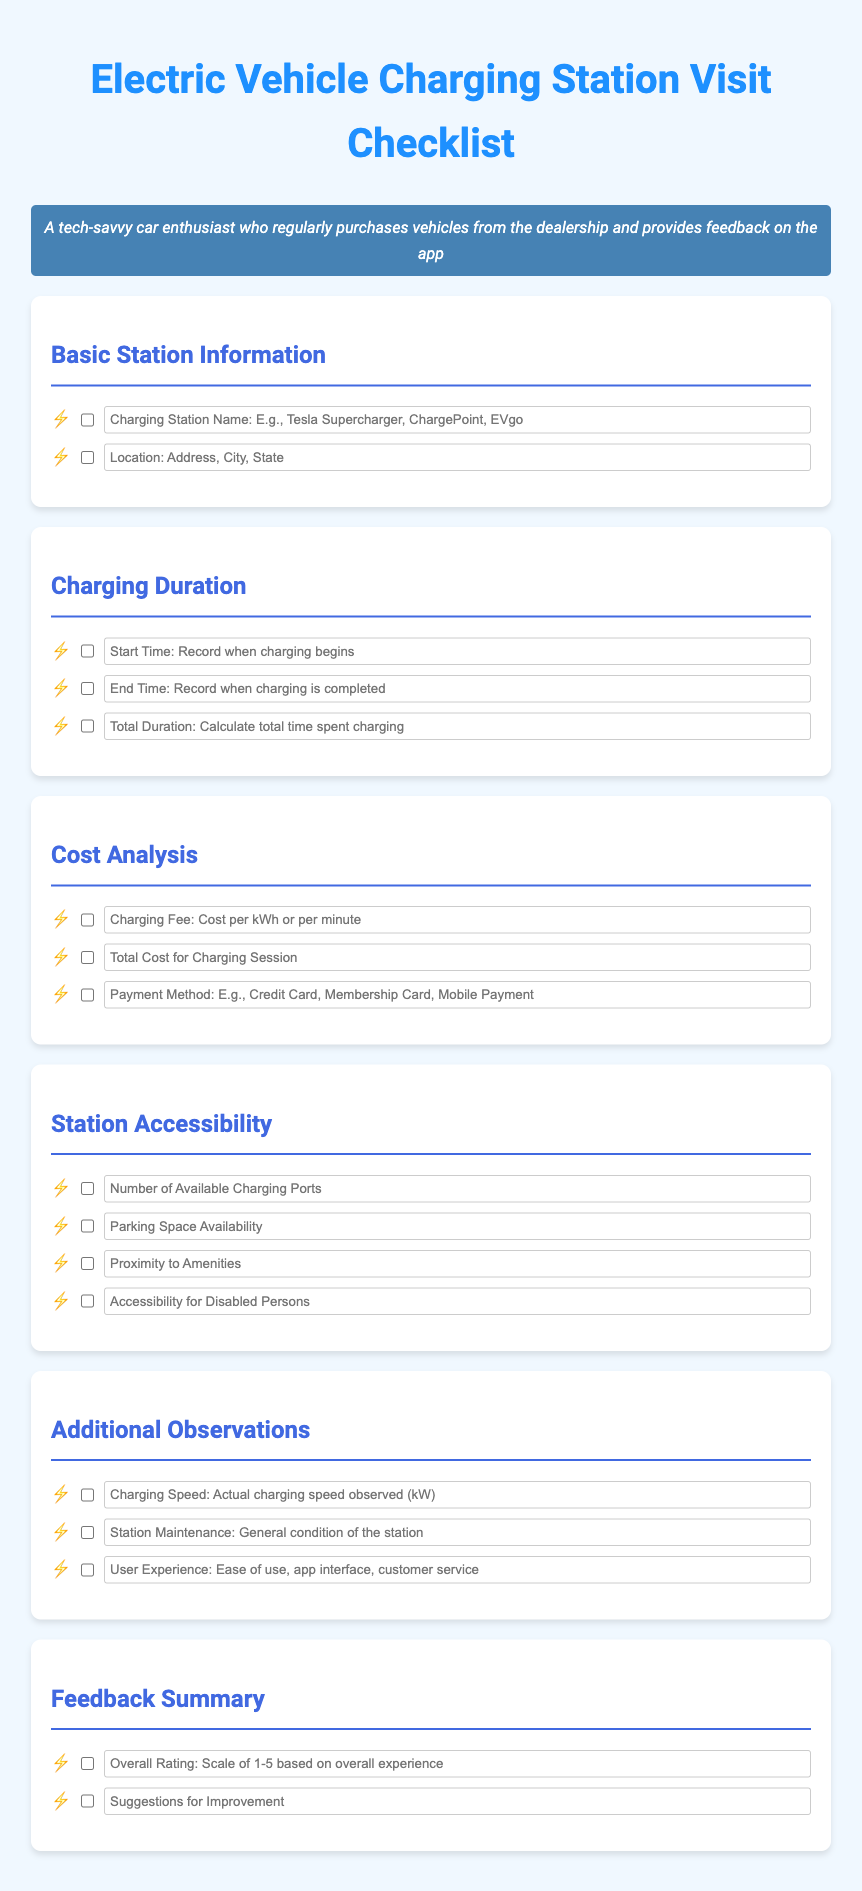what is the title of the document? The title of the document is an important identifying feature found at the top of the rendered checklist.
Answer: Electric Vehicle Charging Station Visit Checklist how many sections are there in the document? The number of sections is indicated by the distinct divisions present in the checklist.
Answer: 6 what is the placeholder for charging station name? The placeholder text provides guidance on what information to input in the respective field.
Answer: Charging Station Name: E.g., Tesla Supercharger, ChargePoint, EVgo what should be recorded as Total Duration? The total duration is calculated based on the start and end times provided in the checklist.
Answer: Calculate total time spent charging what is the format for Overall Rating? The format indicates how users should quantify their experience in a structured manner.
Answer: Scale of 1-5 based on overall experience how many observations are listed under Additional Observations? The number of specific areas for user feedback reflects the detail required in that section.
Answer: 3 what type of information is recorded in the Cost Analysis section? The types of information provide insight into the costs associated with charging electric vehicles at stations.
Answer: Charging Fee, Total Cost for Charging Session, Payment Method which aspect of station accessibility is mentioned for disabled persons? The mention indicates the importance of inclusivity in electric vehicle charging station facilities.
Answer: Accessibility for Disabled Persons what is the suggested format for user suggestions? The expected format guides users on how to provide their thoughts for improvements clearly.
Answer: Suggestions for Improvement 